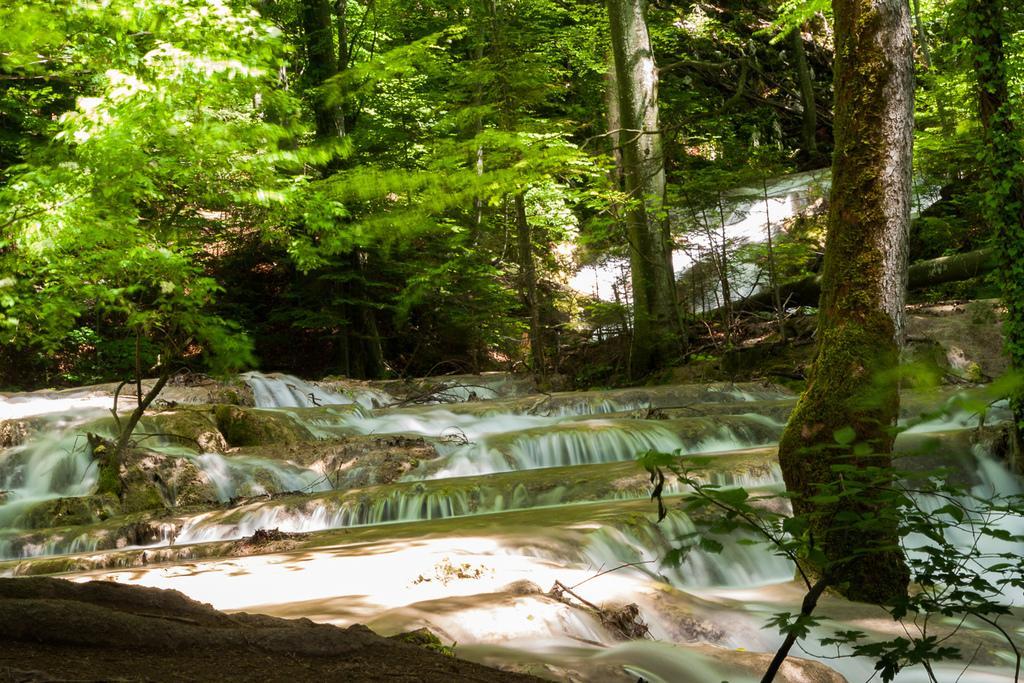Please provide a concise description of this image. In this picture we can see a few plants, trees and waterfalls. 